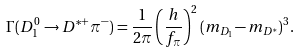<formula> <loc_0><loc_0><loc_500><loc_500>\Gamma ( D _ { 1 } ^ { 0 } \to D ^ { * + } \pi ^ { - } ) = \frac { 1 } { 2 \pi } \left ( \frac { h } { f _ { \pi } } \right ) ^ { 2 } ( m _ { D _ { 1 } } - m _ { D ^ { * } } ) ^ { 3 } .</formula> 